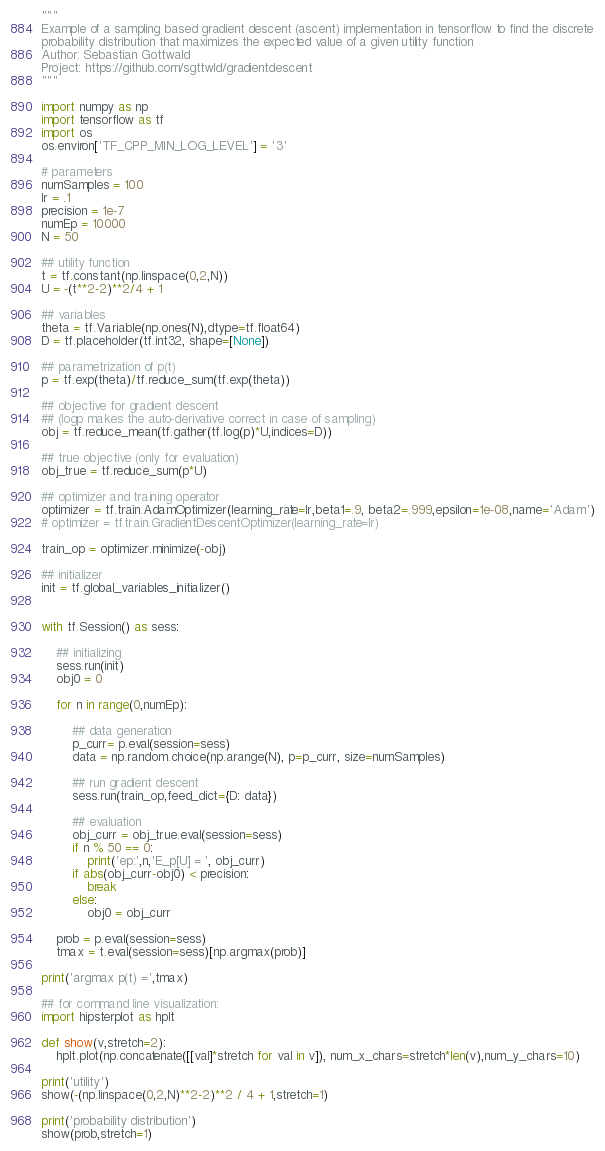<code> <loc_0><loc_0><loc_500><loc_500><_Python_>"""
Example of a sampling based gradient descent (ascent) implementation in tensorflow to find the discrete
probability distribution that maximizes the expected value of a given utility function
Author: Sebastian Gottwald
Project: https://github.com/sgttwld/gradientdescent
"""

import numpy as np
import tensorflow as tf
import os
os.environ['TF_CPP_MIN_LOG_LEVEL'] = '3' 

# parameters
numSamples = 100
lr = .1
precision = 1e-7
numEp = 10000
N = 50      

## utility function
t = tf.constant(np.linspace(0,2,N))
U = -(t**2-2)**2/4 + 1

## variables
theta = tf.Variable(np.ones(N),dtype=tf.float64)
D = tf.placeholder(tf.int32, shape=[None])

## parametrization of p(t)
p = tf.exp(theta)/tf.reduce_sum(tf.exp(theta))

## objective for gradient descent 
## (logp makes the auto-derivative correct in case of sampling) 
obj = tf.reduce_mean(tf.gather(tf.log(p)*U,indices=D))

## true objective (only for evaluation)
obj_true = tf.reduce_sum(p*U)

## optimizer and training operator
optimizer = tf.train.AdamOptimizer(learning_rate=lr,beta1=.9, beta2=.999,epsilon=1e-08,name='Adam')
# optimizer = tf.train.GradientDescentOptimizer(learning_rate=lr)

train_op = optimizer.minimize(-obj)

## initializer
init = tf.global_variables_initializer()
   

with tf.Session() as sess:
 
    ## initializing
    sess.run(init)
    obj0 = 0
        
    for n in range(0,numEp):
    
        ## data generation    
        p_curr= p.eval(session=sess)
        data = np.random.choice(np.arange(N), p=p_curr, size=numSamples)
        
        ## run gradient descent
        sess.run(train_op,feed_dict={D: data})
        
        ## evaluation
        obj_curr = obj_true.eval(session=sess)       
        if n % 50 == 0:
            print('ep:',n,'E_p[U] = ', obj_curr)
        if abs(obj_curr-obj0) < precision:
            break
        else:
            obj0 = obj_curr

    prob = p.eval(session=sess)
    tmax = t.eval(session=sess)[np.argmax(prob)]

print('argmax p(t) =',tmax)

## for command line visualization:
import hipsterplot as hplt

def show(v,stretch=2):
    hplt.plot(np.concatenate([[val]*stretch for val in v]), num_x_chars=stretch*len(v),num_y_chars=10)

print('utility')
show(-(np.linspace(0,2,N)**2-2)**2 / 4 + 1,stretch=1)

print('probability distribution')
show(prob,stretch=1)


</code> 